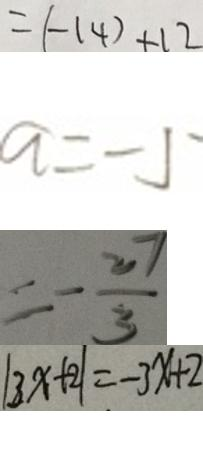<formula> <loc_0><loc_0><loc_500><loc_500>= ( - 1 4 ) + 1 2 
 a = - 5 
 = - \frac { 2 7 } { 3 } 
 \vert 3 x + 2 \vert = - 3 x + 2</formula> 